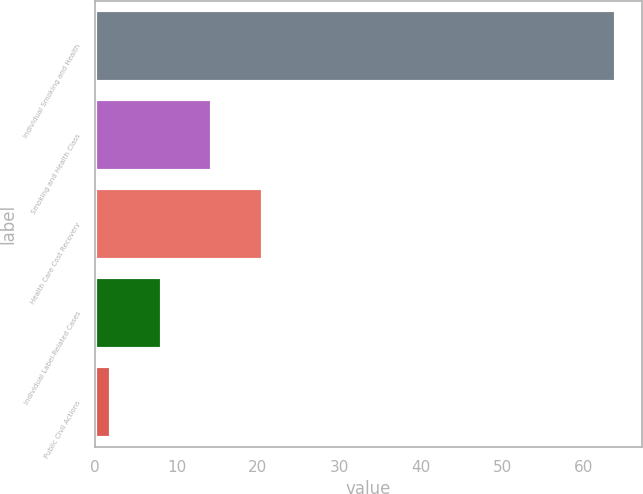<chart> <loc_0><loc_0><loc_500><loc_500><bar_chart><fcel>Individual Smoking and Health<fcel>Smoking and Health Class<fcel>Health Care Cost Recovery<fcel>Individual Label-Related Cases<fcel>Public Civil Actions<nl><fcel>64<fcel>14.4<fcel>20.6<fcel>8.2<fcel>2<nl></chart> 